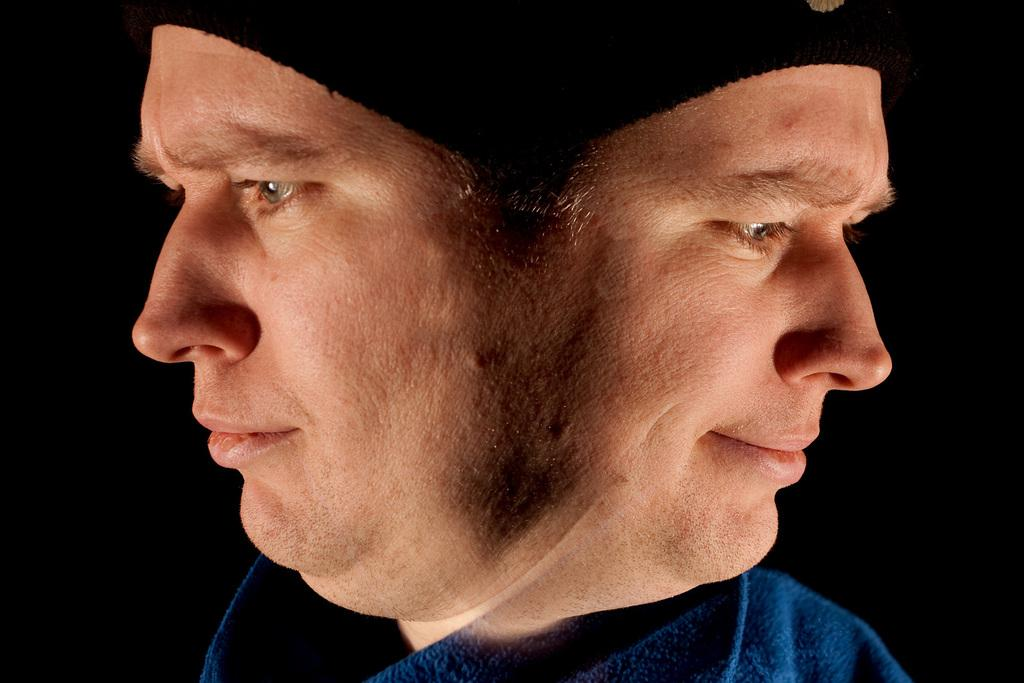What type of picture is in the image? The image contains an edited picture. What color is the dress worn by the person in the image? The person in the image is wearing a blue colored dress. How is the person's face depicted in the image? The person's face has a mirror image. What color is the background of the image? The background of the image is black in color. What type of lead can be seen in the image? There is no lead present in the image. What role does the rail play in the image? There is no rail present in the image. How is the knife used in the image? There is no knife present in the image. 